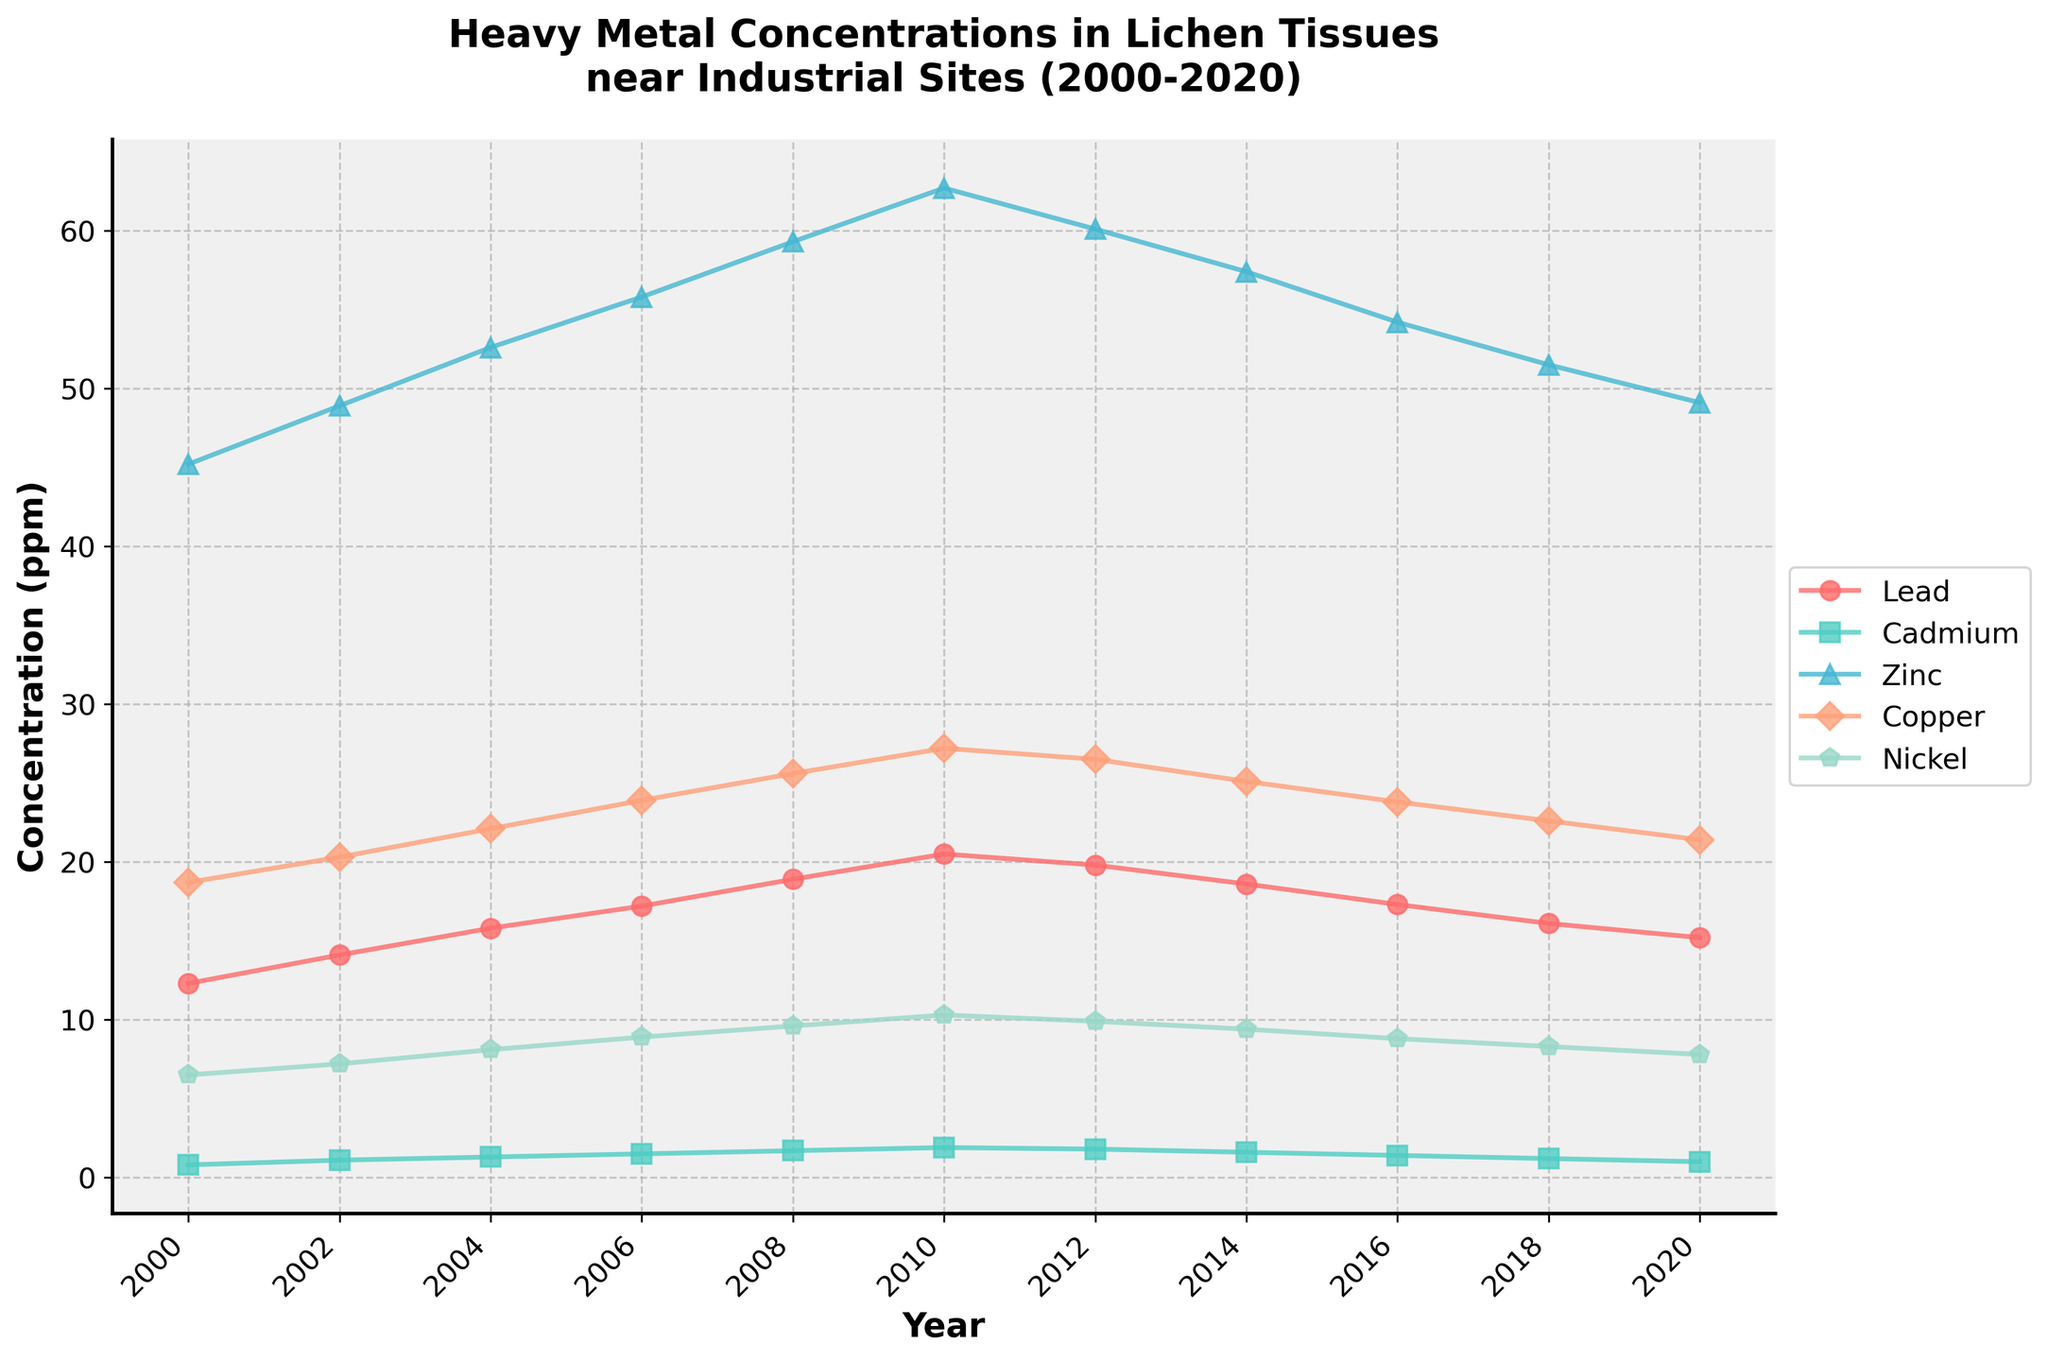What is the trend of Lead concentration from 2000 to 2020? From 2000 to 2010, the Lead concentration increases consistently from 12.3 ppm to 20.5 ppm. After 2010, it decreases steadily each year until 2020, where it reaches 15.2 ppm.
Answer: Upward from 2000 to 2010, downward from 2010 to 2020 Which heavy metal had the highest concentration in 2020? By examining the endpoints of all plotted lines, Zinc clearly has the highest concentration at 49.1 ppm compared to other metals in 2020.
Answer: Zinc How do the concentrations of Cadmium and Nickel in 2012 compare? Both Cadmium and Nickel lines show values for 2012. Cadmium is at 1.8 ppm while Nickel is at 9.9 ppm. Nickel concentration is higher than Cadmium.
Answer: Nickel is higher What year did Copper first surpass 20 ppm? The Copper line hits and moves past the 20 ppm mark from 2002, as indicated by markers on the plot. This is confirmed by the progression from 18.7 ppm in 2000 to 20.3 ppm in 2002.
Answer: 2002 What was the highest concentration of any heavy metal throughout the monitoring period? Looking for the peak of all lines, Zinc reaches its maximum of 62.7 ppm in 2010, which is the highest concentration recorded across all metals during the observed years.
Answer: 62.7 ppm (Zinc) Did any heavy metal concentration decrease continuously from 2010 to 2020? From 2010 to 2020, each plotted metal concentration line descends for Lead, Cadmium, Zinc, Copper, and Nickel, showing continuous decline for these metals.
Answer: Yes What is the difference in Zinc concentration between its peak in 2010 and its value in 2020? Subtracting the concentration in 2020 (49.1 ppm) from the peak value in 2010 (62.7 ppm) yields a difference of 13.6 ppm.
Answer: 13.6 ppm Between which pairs of years does Cadmium concentration remain unchanged? Reviewing the flat portions of the Cadmium line, from 2010 to 2012 and then again from 2012 to 2014 the concentrations remain at 1.9 ppm and 1.8 ppm respectively.
Answer: 2010-2012 and 2012-2014 What is the average concentration of Nickel across the measured period? Adding all Nickel concentrations from 2000 to 2020 (6.5+7.2+8.1+8.9+9.6+10.3+9.9+9.4+8.8+8.3+7.8=94.8) and dividing by the number of years (11) shows the average concentration to be approximately 8.62 ppm.
Answer: 8.62 ppm 